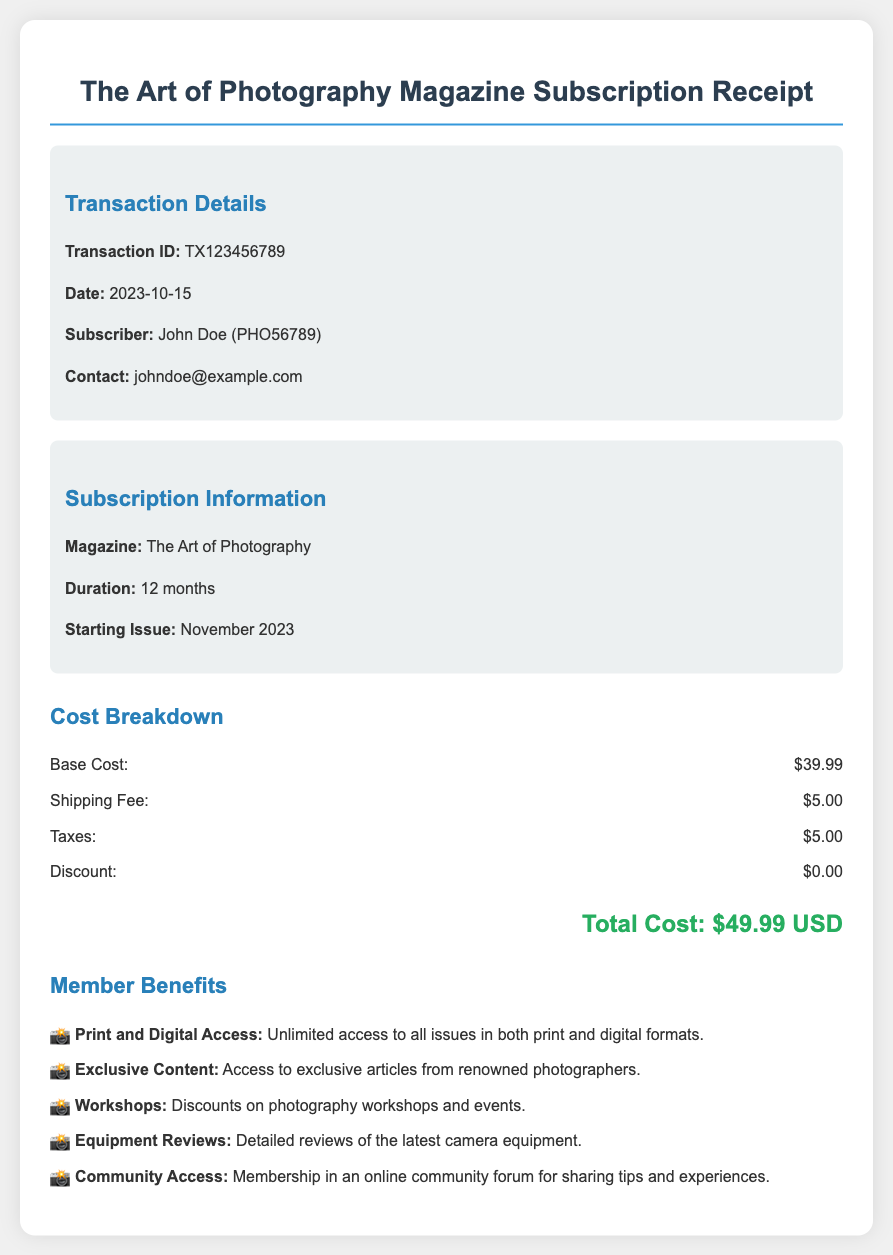What is the transaction ID? The transaction ID is listed under the Transaction Details section of the document.
Answer: TX123456789 What is the cost breakdown for the shipping fee? The shipping fee is explicitly mentioned as part of the cost breakdown in the document.
Answer: $5.00 What is the duration of the subscription? The duration is stated in the Subscription Information section.
Answer: 12 months What is the starting issue for the magazine? The starting issue is mentioned in the Subscription Information section of the document.
Answer: November 2023 What are the member benefits related to equipment? The benefits list includes specific items regarding equipment.
Answer: Detailed reviews of the latest camera equipment What is the total cost of the subscription? The total cost is at the end of the cost breakdown section.
Answer: $49.99 USD Which email address is provided for the subscriber? The email address of the subscriber is given under Transaction Details.
Answer: johndoe@example.com How many member benefits are listed in the document? The number of benefits can be counted in the Member Benefits section.
Answer: Five 